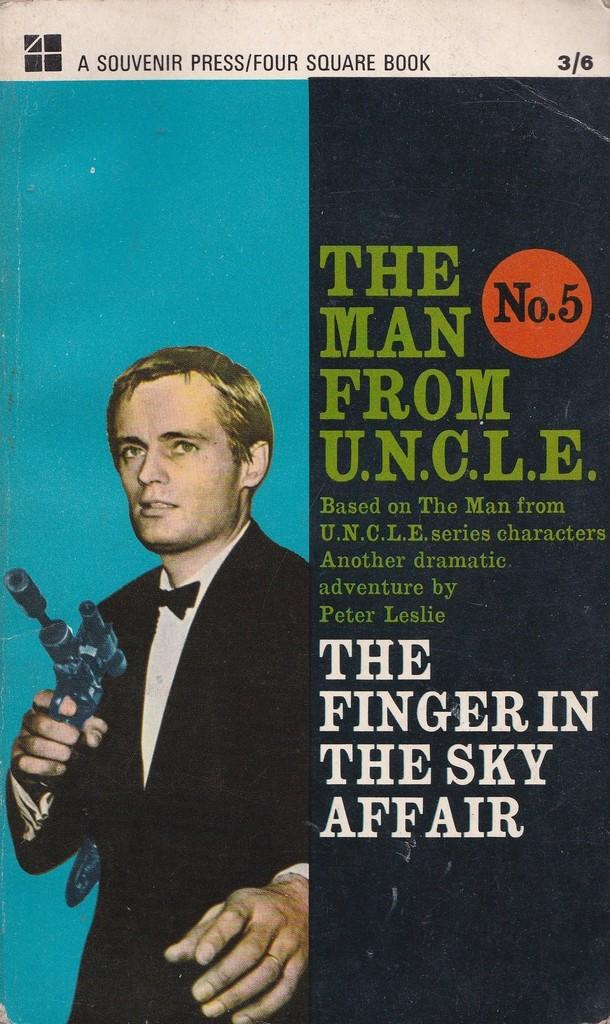What is the main subject of the image? The main subject of the image is a paper. What is depicted on the paper? There is a depiction of a person on the paper. Are there any words or letters on the paper? Yes, there is text on the paper. What type of cow can be seen grazing in the background of the image? There is no cow present in the image; it is a paper with a depiction of a person and text. 